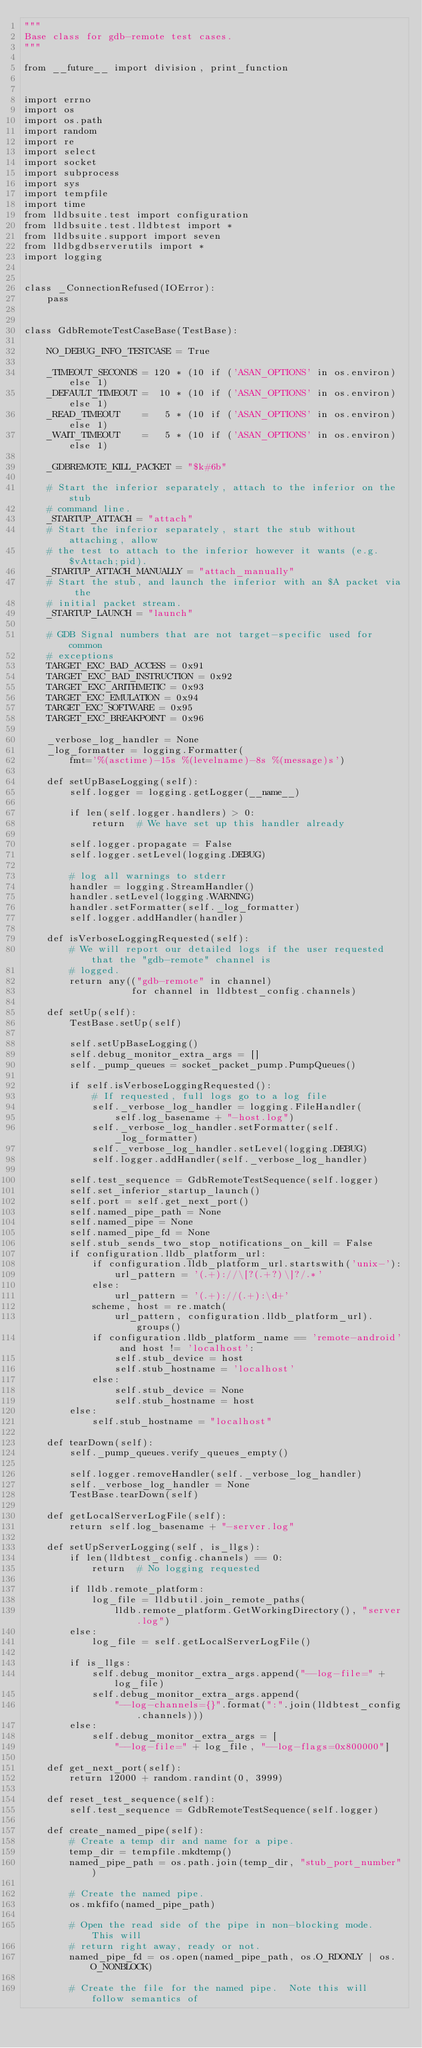<code> <loc_0><loc_0><loc_500><loc_500><_Python_>"""
Base class for gdb-remote test cases.
"""

from __future__ import division, print_function


import errno
import os
import os.path
import random
import re
import select
import socket
import subprocess
import sys
import tempfile
import time
from lldbsuite.test import configuration
from lldbsuite.test.lldbtest import *
from lldbsuite.support import seven
from lldbgdbserverutils import *
import logging


class _ConnectionRefused(IOError):
    pass


class GdbRemoteTestCaseBase(TestBase):

    NO_DEBUG_INFO_TESTCASE = True

    _TIMEOUT_SECONDS = 120 * (10 if ('ASAN_OPTIONS' in os.environ) else 1)
    _DEFAULT_TIMEOUT =  10 * (10 if ('ASAN_OPTIONS' in os.environ) else 1)
    _READ_TIMEOUT    =   5 * (10 if ('ASAN_OPTIONS' in os.environ) else 1)
    _WAIT_TIMEOUT    =   5 * (10 if ('ASAN_OPTIONS' in os.environ) else 1)

    _GDBREMOTE_KILL_PACKET = "$k#6b"

    # Start the inferior separately, attach to the inferior on the stub
    # command line.
    _STARTUP_ATTACH = "attach"
    # Start the inferior separately, start the stub without attaching, allow
    # the test to attach to the inferior however it wants (e.g. $vAttach;pid).
    _STARTUP_ATTACH_MANUALLY = "attach_manually"
    # Start the stub, and launch the inferior with an $A packet via the
    # initial packet stream.
    _STARTUP_LAUNCH = "launch"

    # GDB Signal numbers that are not target-specific used for common
    # exceptions
    TARGET_EXC_BAD_ACCESS = 0x91
    TARGET_EXC_BAD_INSTRUCTION = 0x92
    TARGET_EXC_ARITHMETIC = 0x93
    TARGET_EXC_EMULATION = 0x94
    TARGET_EXC_SOFTWARE = 0x95
    TARGET_EXC_BREAKPOINT = 0x96

    _verbose_log_handler = None
    _log_formatter = logging.Formatter(
        fmt='%(asctime)-15s %(levelname)-8s %(message)s')

    def setUpBaseLogging(self):
        self.logger = logging.getLogger(__name__)

        if len(self.logger.handlers) > 0:
            return  # We have set up this handler already

        self.logger.propagate = False
        self.logger.setLevel(logging.DEBUG)

        # log all warnings to stderr
        handler = logging.StreamHandler()
        handler.setLevel(logging.WARNING)
        handler.setFormatter(self._log_formatter)
        self.logger.addHandler(handler)

    def isVerboseLoggingRequested(self):
        # We will report our detailed logs if the user requested that the "gdb-remote" channel is
        # logged.
        return any(("gdb-remote" in channel)
                   for channel in lldbtest_config.channels)

    def setUp(self):
        TestBase.setUp(self)

        self.setUpBaseLogging()
        self.debug_monitor_extra_args = []
        self._pump_queues = socket_packet_pump.PumpQueues()

        if self.isVerboseLoggingRequested():
            # If requested, full logs go to a log file
            self._verbose_log_handler = logging.FileHandler(
                self.log_basename + "-host.log")
            self._verbose_log_handler.setFormatter(self._log_formatter)
            self._verbose_log_handler.setLevel(logging.DEBUG)
            self.logger.addHandler(self._verbose_log_handler)

        self.test_sequence = GdbRemoteTestSequence(self.logger)
        self.set_inferior_startup_launch()
        self.port = self.get_next_port()
        self.named_pipe_path = None
        self.named_pipe = None
        self.named_pipe_fd = None
        self.stub_sends_two_stop_notifications_on_kill = False
        if configuration.lldb_platform_url:
            if configuration.lldb_platform_url.startswith('unix-'):
                url_pattern = '(.+)://\[?(.+?)\]?/.*'
            else:
                url_pattern = '(.+)://(.+):\d+'
            scheme, host = re.match(
                url_pattern, configuration.lldb_platform_url).groups()
            if configuration.lldb_platform_name == 'remote-android' and host != 'localhost':
                self.stub_device = host
                self.stub_hostname = 'localhost'
            else:
                self.stub_device = None
                self.stub_hostname = host
        else:
            self.stub_hostname = "localhost"

    def tearDown(self):
        self._pump_queues.verify_queues_empty()

        self.logger.removeHandler(self._verbose_log_handler)
        self._verbose_log_handler = None
        TestBase.tearDown(self)

    def getLocalServerLogFile(self):
        return self.log_basename + "-server.log"

    def setUpServerLogging(self, is_llgs):
        if len(lldbtest_config.channels) == 0:
            return  # No logging requested

        if lldb.remote_platform:
            log_file = lldbutil.join_remote_paths(
                lldb.remote_platform.GetWorkingDirectory(), "server.log")
        else:
            log_file = self.getLocalServerLogFile()

        if is_llgs:
            self.debug_monitor_extra_args.append("--log-file=" + log_file)
            self.debug_monitor_extra_args.append(
                "--log-channels={}".format(":".join(lldbtest_config.channels)))
        else:
            self.debug_monitor_extra_args = [
                "--log-file=" + log_file, "--log-flags=0x800000"]

    def get_next_port(self):
        return 12000 + random.randint(0, 3999)

    def reset_test_sequence(self):
        self.test_sequence = GdbRemoteTestSequence(self.logger)

    def create_named_pipe(self):
        # Create a temp dir and name for a pipe.
        temp_dir = tempfile.mkdtemp()
        named_pipe_path = os.path.join(temp_dir, "stub_port_number")

        # Create the named pipe.
        os.mkfifo(named_pipe_path)

        # Open the read side of the pipe in non-blocking mode.  This will
        # return right away, ready or not.
        named_pipe_fd = os.open(named_pipe_path, os.O_RDONLY | os.O_NONBLOCK)

        # Create the file for the named pipe.  Note this will follow semantics of</code> 